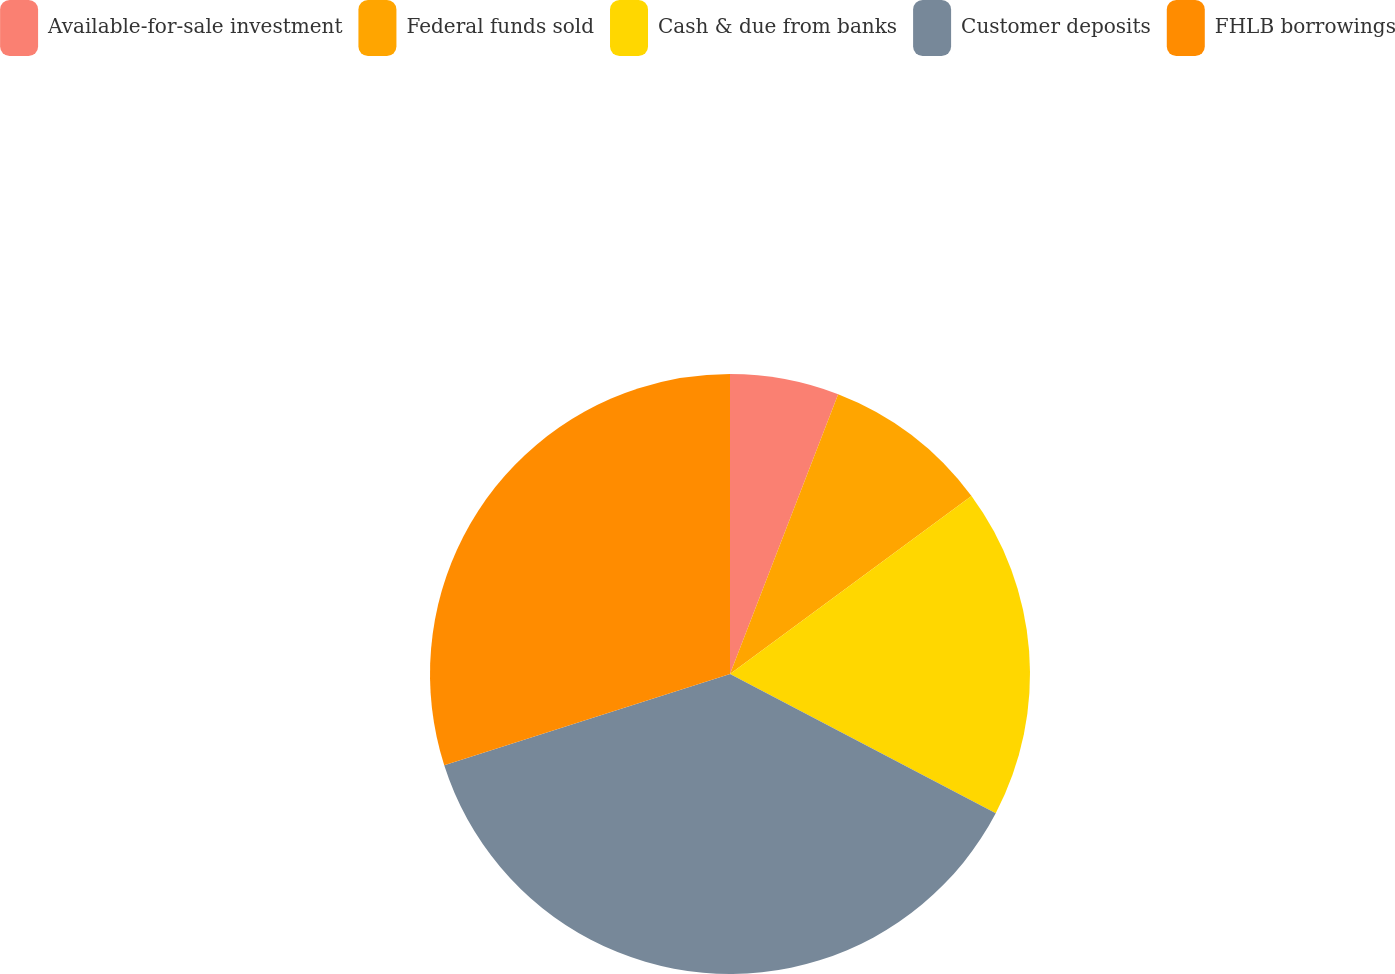Convert chart. <chart><loc_0><loc_0><loc_500><loc_500><pie_chart><fcel>Available-for-sale investment<fcel>Federal funds sold<fcel>Cash & due from banks<fcel>Customer deposits<fcel>FHLB borrowings<nl><fcel>5.87%<fcel>9.02%<fcel>17.79%<fcel>37.4%<fcel>29.92%<nl></chart> 